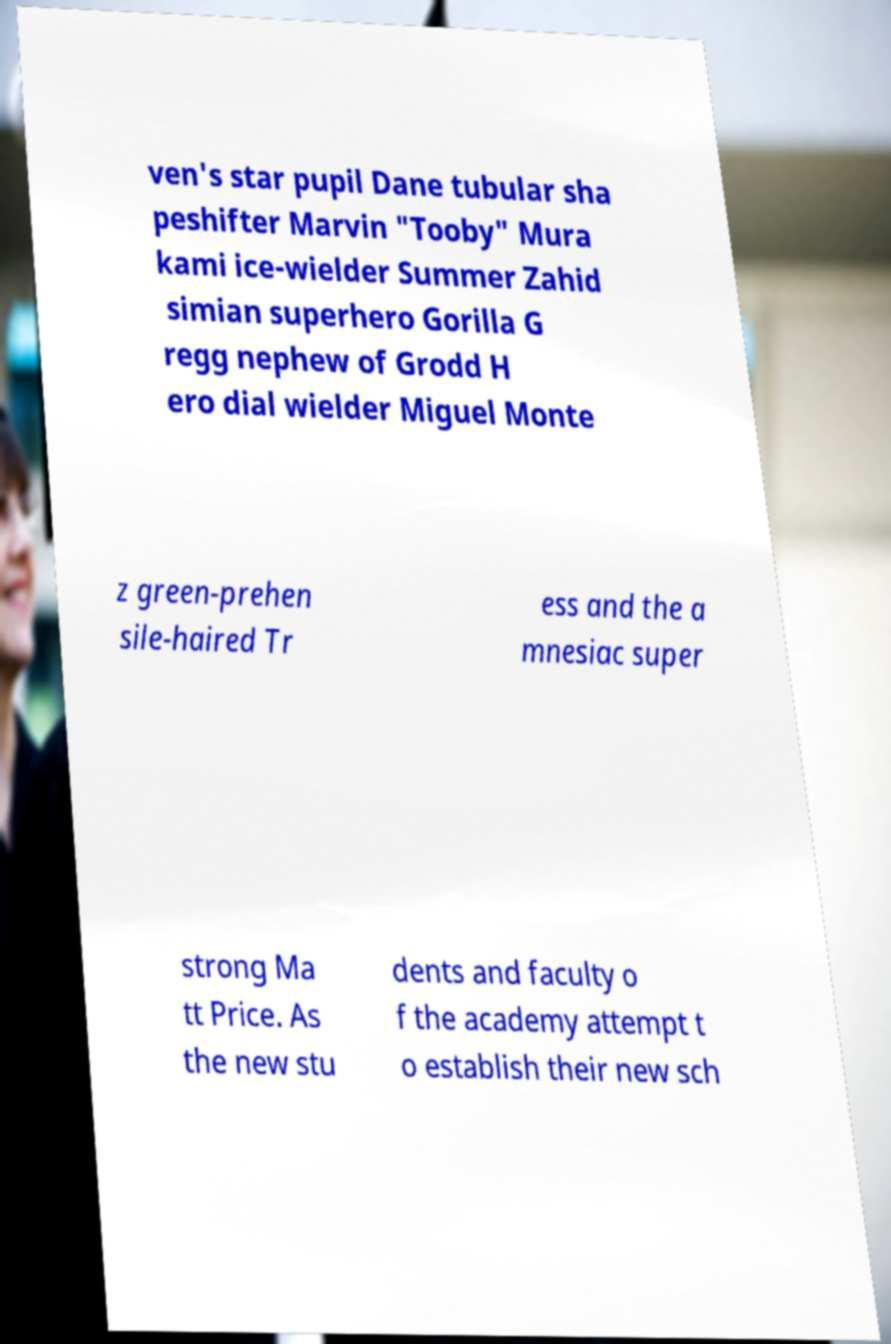What messages or text are displayed in this image? I need them in a readable, typed format. ven's star pupil Dane tubular sha peshifter Marvin "Tooby" Mura kami ice-wielder Summer Zahid simian superhero Gorilla G regg nephew of Grodd H ero dial wielder Miguel Monte z green-prehen sile-haired Tr ess and the a mnesiac super strong Ma tt Price. As the new stu dents and faculty o f the academy attempt t o establish their new sch 